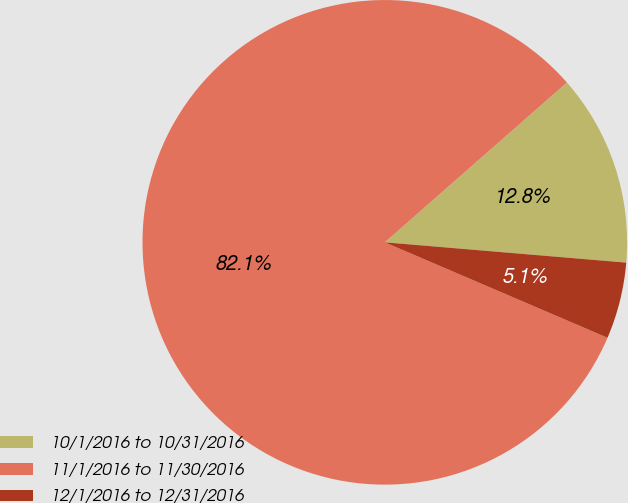<chart> <loc_0><loc_0><loc_500><loc_500><pie_chart><fcel>10/1/2016 to 10/31/2016<fcel>11/1/2016 to 11/30/2016<fcel>12/1/2016 to 12/31/2016<nl><fcel>12.8%<fcel>82.09%<fcel>5.11%<nl></chart> 